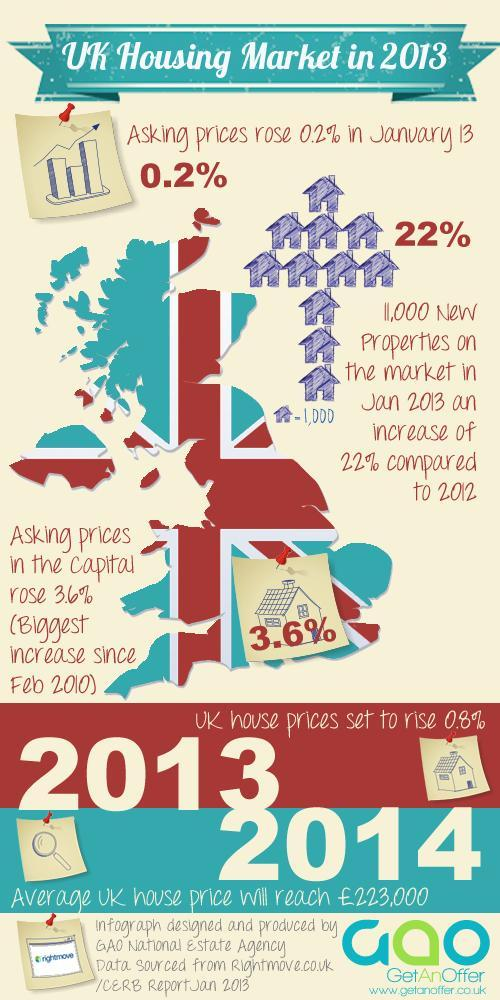What was the % increase in new properties in 2013 when compared to 2012
Answer the question with a short phrase. 22% How much more in % did the asking price rise in London when compared to the overall UK housing market 3.4 WHat will be the asking price rise in UK in 2013 0.8% 